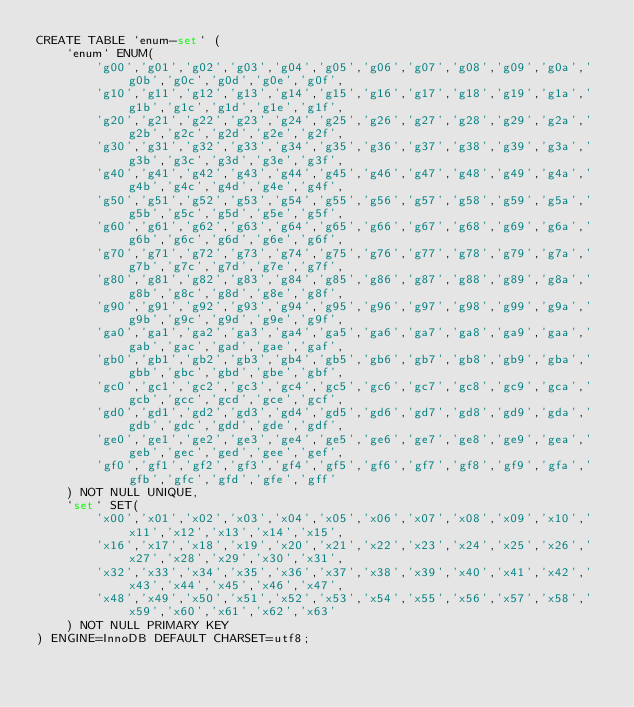<code> <loc_0><loc_0><loc_500><loc_500><_SQL_>CREATE TABLE `enum-set` (
    `enum` ENUM(
        'g00','g01','g02','g03','g04','g05','g06','g07','g08','g09','g0a','g0b','g0c','g0d','g0e','g0f',
        'g10','g11','g12','g13','g14','g15','g16','g17','g18','g19','g1a','g1b','g1c','g1d','g1e','g1f',
        'g20','g21','g22','g23','g24','g25','g26','g27','g28','g29','g2a','g2b','g2c','g2d','g2e','g2f',
        'g30','g31','g32','g33','g34','g35','g36','g37','g38','g39','g3a','g3b','g3c','g3d','g3e','g3f',
        'g40','g41','g42','g43','g44','g45','g46','g47','g48','g49','g4a','g4b','g4c','g4d','g4e','g4f',
        'g50','g51','g52','g53','g54','g55','g56','g57','g58','g59','g5a','g5b','g5c','g5d','g5e','g5f',
        'g60','g61','g62','g63','g64','g65','g66','g67','g68','g69','g6a','g6b','g6c','g6d','g6e','g6f',
        'g70','g71','g72','g73','g74','g75','g76','g77','g78','g79','g7a','g7b','g7c','g7d','g7e','g7f',
        'g80','g81','g82','g83','g84','g85','g86','g87','g88','g89','g8a','g8b','g8c','g8d','g8e','g8f',
        'g90','g91','g92','g93','g94','g95','g96','g97','g98','g99','g9a','g9b','g9c','g9d','g9e','g9f',
        'ga0','ga1','ga2','ga3','ga4','ga5','ga6','ga7','ga8','ga9','gaa','gab','gac','gad','gae','gaf',
        'gb0','gb1','gb2','gb3','gb4','gb5','gb6','gb7','gb8','gb9','gba','gbb','gbc','gbd','gbe','gbf',
        'gc0','gc1','gc2','gc3','gc4','gc5','gc6','gc7','gc8','gc9','gca','gcb','gcc','gcd','gce','gcf',
        'gd0','gd1','gd2','gd3','gd4','gd5','gd6','gd7','gd8','gd9','gda','gdb','gdc','gdd','gde','gdf',
        'ge0','ge1','ge2','ge3','ge4','ge5','ge6','ge7','ge8','ge9','gea','geb','gec','ged','gee','gef',
        'gf0','gf1','gf2','gf3','gf4','gf5','gf6','gf7','gf8','gf9','gfa','gfb','gfc','gfd','gfe','gff'
    ) NOT NULL UNIQUE,
    `set` SET(
        'x00','x01','x02','x03','x04','x05','x06','x07','x08','x09','x10','x11','x12','x13','x14','x15',
        'x16','x17','x18','x19','x20','x21','x22','x23','x24','x25','x26','x27','x28','x29','x30','x31',
        'x32','x33','x34','x35','x36','x37','x38','x39','x40','x41','x42','x43','x44','x45','x46','x47',
        'x48','x49','x50','x51','x52','x53','x54','x55','x56','x57','x58','x59','x60','x61','x62','x63'
    ) NOT NULL PRIMARY KEY
) ENGINE=InnoDB DEFAULT CHARSET=utf8;
</code> 